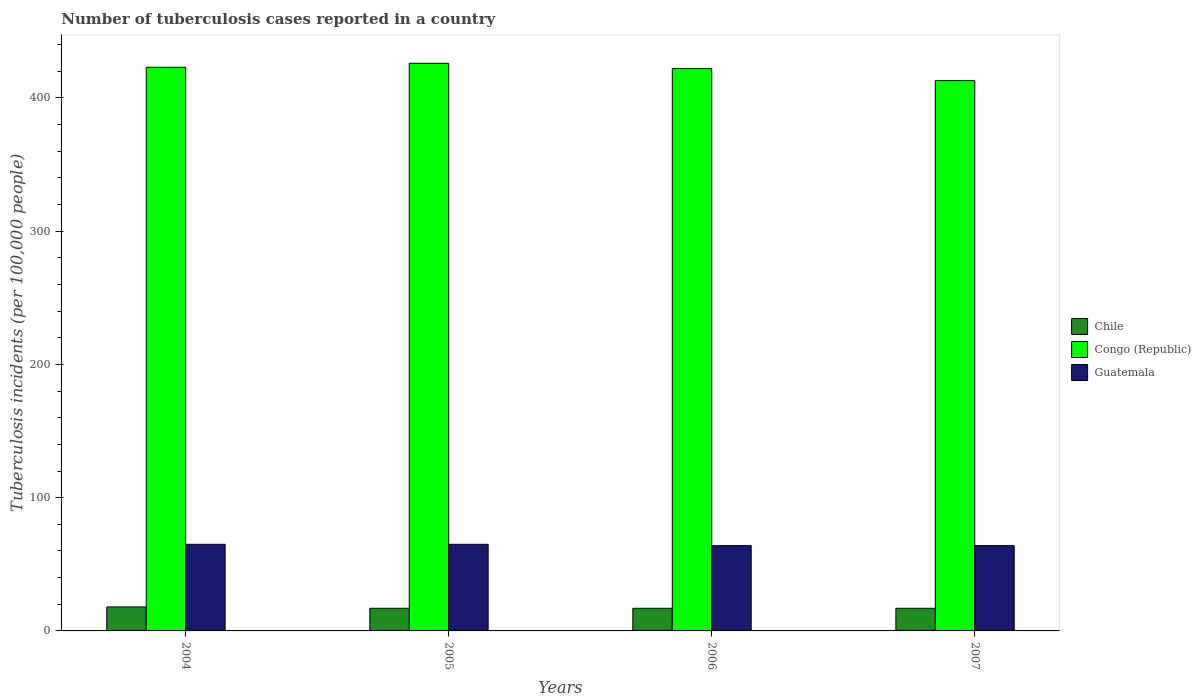Are the number of bars per tick equal to the number of legend labels?
Your response must be concise. Yes. How many bars are there on the 1st tick from the left?
Give a very brief answer. 3. How many bars are there on the 3rd tick from the right?
Your answer should be compact. 3. What is the number of tuberculosis cases reported in in Guatemala in 2006?
Your response must be concise. 64. Across all years, what is the maximum number of tuberculosis cases reported in in Guatemala?
Your answer should be compact. 65. Across all years, what is the minimum number of tuberculosis cases reported in in Chile?
Provide a succinct answer. 17. What is the total number of tuberculosis cases reported in in Chile in the graph?
Offer a terse response. 69. What is the difference between the number of tuberculosis cases reported in in Congo (Republic) in 2004 and that in 2005?
Your response must be concise. -3. What is the difference between the number of tuberculosis cases reported in in Chile in 2005 and the number of tuberculosis cases reported in in Guatemala in 2004?
Provide a short and direct response. -48. What is the average number of tuberculosis cases reported in in Chile per year?
Your answer should be very brief. 17.25. In the year 2007, what is the difference between the number of tuberculosis cases reported in in Guatemala and number of tuberculosis cases reported in in Congo (Republic)?
Offer a very short reply. -349. What is the ratio of the number of tuberculosis cases reported in in Guatemala in 2004 to that in 2007?
Your answer should be very brief. 1.02. What is the difference between the highest and the second highest number of tuberculosis cases reported in in Guatemala?
Provide a short and direct response. 0. What is the difference between the highest and the lowest number of tuberculosis cases reported in in Congo (Republic)?
Offer a very short reply. 13. Is the sum of the number of tuberculosis cases reported in in Chile in 2004 and 2007 greater than the maximum number of tuberculosis cases reported in in Congo (Republic) across all years?
Make the answer very short. No. What does the 3rd bar from the left in 2004 represents?
Offer a terse response. Guatemala. What does the 1st bar from the right in 2004 represents?
Provide a short and direct response. Guatemala. Is it the case that in every year, the sum of the number of tuberculosis cases reported in in Guatemala and number of tuberculosis cases reported in in Chile is greater than the number of tuberculosis cases reported in in Congo (Republic)?
Provide a succinct answer. No. Are all the bars in the graph horizontal?
Ensure brevity in your answer.  No. How many years are there in the graph?
Your response must be concise. 4. What is the difference between two consecutive major ticks on the Y-axis?
Offer a very short reply. 100. Does the graph contain any zero values?
Keep it short and to the point. No. How many legend labels are there?
Ensure brevity in your answer.  3. What is the title of the graph?
Your answer should be very brief. Number of tuberculosis cases reported in a country. Does "Belgium" appear as one of the legend labels in the graph?
Your answer should be very brief. No. What is the label or title of the X-axis?
Offer a terse response. Years. What is the label or title of the Y-axis?
Ensure brevity in your answer.  Tuberculosis incidents (per 100,0 people). What is the Tuberculosis incidents (per 100,000 people) in Chile in 2004?
Provide a succinct answer. 18. What is the Tuberculosis incidents (per 100,000 people) in Congo (Republic) in 2004?
Your response must be concise. 423. What is the Tuberculosis incidents (per 100,000 people) in Guatemala in 2004?
Provide a succinct answer. 65. What is the Tuberculosis incidents (per 100,000 people) in Congo (Republic) in 2005?
Offer a terse response. 426. What is the Tuberculosis incidents (per 100,000 people) in Chile in 2006?
Offer a terse response. 17. What is the Tuberculosis incidents (per 100,000 people) of Congo (Republic) in 2006?
Offer a very short reply. 422. What is the Tuberculosis incidents (per 100,000 people) in Guatemala in 2006?
Ensure brevity in your answer.  64. What is the Tuberculosis incidents (per 100,000 people) of Chile in 2007?
Offer a terse response. 17. What is the Tuberculosis incidents (per 100,000 people) in Congo (Republic) in 2007?
Provide a succinct answer. 413. What is the Tuberculosis incidents (per 100,000 people) in Guatemala in 2007?
Provide a short and direct response. 64. Across all years, what is the maximum Tuberculosis incidents (per 100,000 people) in Congo (Republic)?
Your answer should be very brief. 426. Across all years, what is the maximum Tuberculosis incidents (per 100,000 people) of Guatemala?
Ensure brevity in your answer.  65. Across all years, what is the minimum Tuberculosis incidents (per 100,000 people) in Chile?
Provide a succinct answer. 17. Across all years, what is the minimum Tuberculosis incidents (per 100,000 people) in Congo (Republic)?
Ensure brevity in your answer.  413. Across all years, what is the minimum Tuberculosis incidents (per 100,000 people) in Guatemala?
Your answer should be very brief. 64. What is the total Tuberculosis incidents (per 100,000 people) of Chile in the graph?
Provide a succinct answer. 69. What is the total Tuberculosis incidents (per 100,000 people) of Congo (Republic) in the graph?
Your answer should be compact. 1684. What is the total Tuberculosis incidents (per 100,000 people) in Guatemala in the graph?
Offer a terse response. 258. What is the difference between the Tuberculosis incidents (per 100,000 people) of Chile in 2004 and that in 2005?
Offer a terse response. 1. What is the difference between the Tuberculosis incidents (per 100,000 people) of Guatemala in 2004 and that in 2005?
Provide a succinct answer. 0. What is the difference between the Tuberculosis incidents (per 100,000 people) of Congo (Republic) in 2004 and that in 2006?
Provide a short and direct response. 1. What is the difference between the Tuberculosis incidents (per 100,000 people) of Chile in 2004 and that in 2007?
Your answer should be compact. 1. What is the difference between the Tuberculosis incidents (per 100,000 people) in Chile in 2005 and that in 2006?
Offer a terse response. 0. What is the difference between the Tuberculosis incidents (per 100,000 people) of Guatemala in 2005 and that in 2006?
Make the answer very short. 1. What is the difference between the Tuberculosis incidents (per 100,000 people) of Chile in 2005 and that in 2007?
Offer a terse response. 0. What is the difference between the Tuberculosis incidents (per 100,000 people) of Congo (Republic) in 2005 and that in 2007?
Give a very brief answer. 13. What is the difference between the Tuberculosis incidents (per 100,000 people) in Guatemala in 2005 and that in 2007?
Provide a succinct answer. 1. What is the difference between the Tuberculosis incidents (per 100,000 people) in Congo (Republic) in 2006 and that in 2007?
Ensure brevity in your answer.  9. What is the difference between the Tuberculosis incidents (per 100,000 people) in Chile in 2004 and the Tuberculosis incidents (per 100,000 people) in Congo (Republic) in 2005?
Offer a terse response. -408. What is the difference between the Tuberculosis incidents (per 100,000 people) of Chile in 2004 and the Tuberculosis incidents (per 100,000 people) of Guatemala in 2005?
Make the answer very short. -47. What is the difference between the Tuberculosis incidents (per 100,000 people) in Congo (Republic) in 2004 and the Tuberculosis incidents (per 100,000 people) in Guatemala in 2005?
Make the answer very short. 358. What is the difference between the Tuberculosis incidents (per 100,000 people) in Chile in 2004 and the Tuberculosis incidents (per 100,000 people) in Congo (Republic) in 2006?
Your response must be concise. -404. What is the difference between the Tuberculosis incidents (per 100,000 people) in Chile in 2004 and the Tuberculosis incidents (per 100,000 people) in Guatemala in 2006?
Your answer should be compact. -46. What is the difference between the Tuberculosis incidents (per 100,000 people) of Congo (Republic) in 2004 and the Tuberculosis incidents (per 100,000 people) of Guatemala in 2006?
Give a very brief answer. 359. What is the difference between the Tuberculosis incidents (per 100,000 people) of Chile in 2004 and the Tuberculosis incidents (per 100,000 people) of Congo (Republic) in 2007?
Ensure brevity in your answer.  -395. What is the difference between the Tuberculosis incidents (per 100,000 people) of Chile in 2004 and the Tuberculosis incidents (per 100,000 people) of Guatemala in 2007?
Your answer should be compact. -46. What is the difference between the Tuberculosis incidents (per 100,000 people) of Congo (Republic) in 2004 and the Tuberculosis incidents (per 100,000 people) of Guatemala in 2007?
Offer a very short reply. 359. What is the difference between the Tuberculosis incidents (per 100,000 people) in Chile in 2005 and the Tuberculosis incidents (per 100,000 people) in Congo (Republic) in 2006?
Your answer should be very brief. -405. What is the difference between the Tuberculosis incidents (per 100,000 people) of Chile in 2005 and the Tuberculosis incidents (per 100,000 people) of Guatemala in 2006?
Your answer should be compact. -47. What is the difference between the Tuberculosis incidents (per 100,000 people) of Congo (Republic) in 2005 and the Tuberculosis incidents (per 100,000 people) of Guatemala in 2006?
Provide a succinct answer. 362. What is the difference between the Tuberculosis incidents (per 100,000 people) of Chile in 2005 and the Tuberculosis incidents (per 100,000 people) of Congo (Republic) in 2007?
Give a very brief answer. -396. What is the difference between the Tuberculosis incidents (per 100,000 people) in Chile in 2005 and the Tuberculosis incidents (per 100,000 people) in Guatemala in 2007?
Keep it short and to the point. -47. What is the difference between the Tuberculosis incidents (per 100,000 people) of Congo (Republic) in 2005 and the Tuberculosis incidents (per 100,000 people) of Guatemala in 2007?
Ensure brevity in your answer.  362. What is the difference between the Tuberculosis incidents (per 100,000 people) in Chile in 2006 and the Tuberculosis incidents (per 100,000 people) in Congo (Republic) in 2007?
Offer a terse response. -396. What is the difference between the Tuberculosis incidents (per 100,000 people) in Chile in 2006 and the Tuberculosis incidents (per 100,000 people) in Guatemala in 2007?
Offer a very short reply. -47. What is the difference between the Tuberculosis incidents (per 100,000 people) in Congo (Republic) in 2006 and the Tuberculosis incidents (per 100,000 people) in Guatemala in 2007?
Provide a short and direct response. 358. What is the average Tuberculosis incidents (per 100,000 people) of Chile per year?
Offer a terse response. 17.25. What is the average Tuberculosis incidents (per 100,000 people) of Congo (Republic) per year?
Keep it short and to the point. 421. What is the average Tuberculosis incidents (per 100,000 people) of Guatemala per year?
Make the answer very short. 64.5. In the year 2004, what is the difference between the Tuberculosis incidents (per 100,000 people) in Chile and Tuberculosis incidents (per 100,000 people) in Congo (Republic)?
Make the answer very short. -405. In the year 2004, what is the difference between the Tuberculosis incidents (per 100,000 people) in Chile and Tuberculosis incidents (per 100,000 people) in Guatemala?
Provide a short and direct response. -47. In the year 2004, what is the difference between the Tuberculosis incidents (per 100,000 people) of Congo (Republic) and Tuberculosis incidents (per 100,000 people) of Guatemala?
Keep it short and to the point. 358. In the year 2005, what is the difference between the Tuberculosis incidents (per 100,000 people) in Chile and Tuberculosis incidents (per 100,000 people) in Congo (Republic)?
Keep it short and to the point. -409. In the year 2005, what is the difference between the Tuberculosis incidents (per 100,000 people) in Chile and Tuberculosis incidents (per 100,000 people) in Guatemala?
Keep it short and to the point. -48. In the year 2005, what is the difference between the Tuberculosis incidents (per 100,000 people) in Congo (Republic) and Tuberculosis incidents (per 100,000 people) in Guatemala?
Your answer should be very brief. 361. In the year 2006, what is the difference between the Tuberculosis incidents (per 100,000 people) in Chile and Tuberculosis incidents (per 100,000 people) in Congo (Republic)?
Your answer should be compact. -405. In the year 2006, what is the difference between the Tuberculosis incidents (per 100,000 people) of Chile and Tuberculosis incidents (per 100,000 people) of Guatemala?
Make the answer very short. -47. In the year 2006, what is the difference between the Tuberculosis incidents (per 100,000 people) of Congo (Republic) and Tuberculosis incidents (per 100,000 people) of Guatemala?
Your answer should be compact. 358. In the year 2007, what is the difference between the Tuberculosis incidents (per 100,000 people) in Chile and Tuberculosis incidents (per 100,000 people) in Congo (Republic)?
Your answer should be very brief. -396. In the year 2007, what is the difference between the Tuberculosis incidents (per 100,000 people) in Chile and Tuberculosis incidents (per 100,000 people) in Guatemala?
Your response must be concise. -47. In the year 2007, what is the difference between the Tuberculosis incidents (per 100,000 people) of Congo (Republic) and Tuberculosis incidents (per 100,000 people) of Guatemala?
Provide a succinct answer. 349. What is the ratio of the Tuberculosis incidents (per 100,000 people) in Chile in 2004 to that in 2005?
Provide a succinct answer. 1.06. What is the ratio of the Tuberculosis incidents (per 100,000 people) of Congo (Republic) in 2004 to that in 2005?
Your answer should be compact. 0.99. What is the ratio of the Tuberculosis incidents (per 100,000 people) in Guatemala in 2004 to that in 2005?
Your response must be concise. 1. What is the ratio of the Tuberculosis incidents (per 100,000 people) in Chile in 2004 to that in 2006?
Keep it short and to the point. 1.06. What is the ratio of the Tuberculosis incidents (per 100,000 people) of Guatemala in 2004 to that in 2006?
Give a very brief answer. 1.02. What is the ratio of the Tuberculosis incidents (per 100,000 people) of Chile in 2004 to that in 2007?
Ensure brevity in your answer.  1.06. What is the ratio of the Tuberculosis incidents (per 100,000 people) of Congo (Republic) in 2004 to that in 2007?
Offer a terse response. 1.02. What is the ratio of the Tuberculosis incidents (per 100,000 people) of Guatemala in 2004 to that in 2007?
Provide a succinct answer. 1.02. What is the ratio of the Tuberculosis incidents (per 100,000 people) in Congo (Republic) in 2005 to that in 2006?
Your answer should be compact. 1.01. What is the ratio of the Tuberculosis incidents (per 100,000 people) of Guatemala in 2005 to that in 2006?
Keep it short and to the point. 1.02. What is the ratio of the Tuberculosis incidents (per 100,000 people) in Congo (Republic) in 2005 to that in 2007?
Ensure brevity in your answer.  1.03. What is the ratio of the Tuberculosis incidents (per 100,000 people) in Guatemala in 2005 to that in 2007?
Give a very brief answer. 1.02. What is the ratio of the Tuberculosis incidents (per 100,000 people) of Congo (Republic) in 2006 to that in 2007?
Offer a terse response. 1.02. What is the difference between the highest and the second highest Tuberculosis incidents (per 100,000 people) of Chile?
Offer a terse response. 1. What is the difference between the highest and the second highest Tuberculosis incidents (per 100,000 people) in Congo (Republic)?
Provide a succinct answer. 3. What is the difference between the highest and the lowest Tuberculosis incidents (per 100,000 people) in Chile?
Make the answer very short. 1. What is the difference between the highest and the lowest Tuberculosis incidents (per 100,000 people) in Congo (Republic)?
Offer a terse response. 13. What is the difference between the highest and the lowest Tuberculosis incidents (per 100,000 people) in Guatemala?
Make the answer very short. 1. 